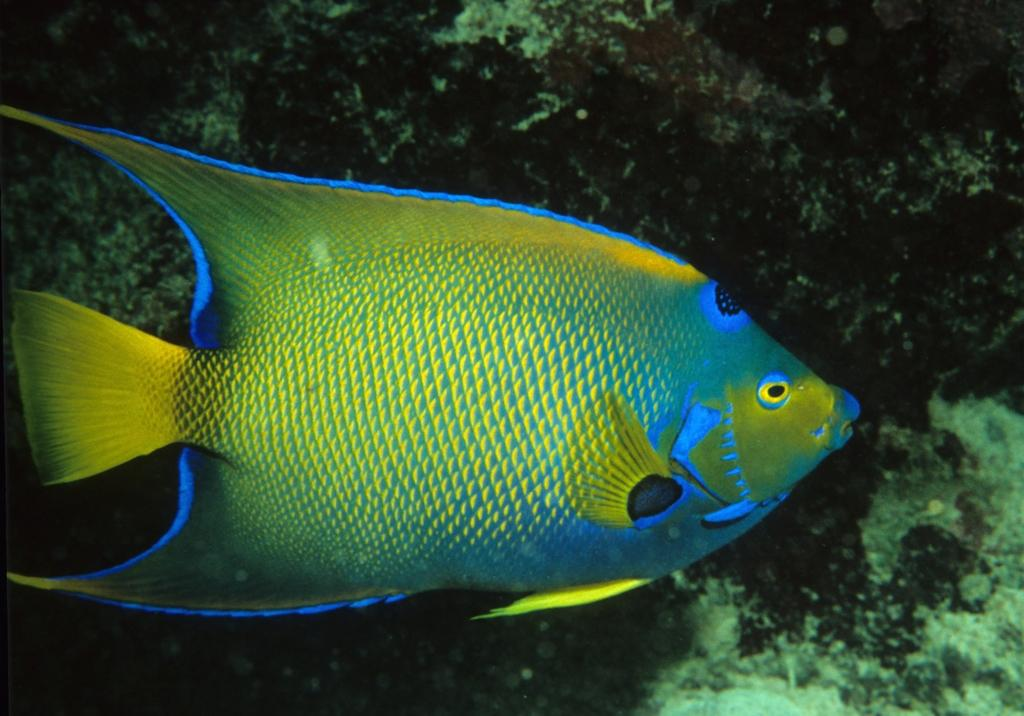What is in the water in the image? There is a fish in the water in the image. How is the fish visually distinct in the image? The fish is shining with a yellow color and has blue borders. What else can be seen in the water besides the fish? Water plants are visible in the image. What type of tooth can be seen in the image? There are no teeth present in the image; it features a fish in the water with water plants. Is there a current visible in the image? The provided facts do not mention a current in the image, only the presence of a fish, its appearance, and water plants. 